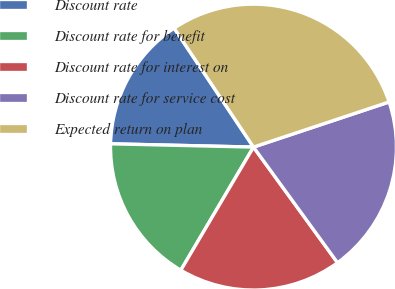<chart> <loc_0><loc_0><loc_500><loc_500><pie_chart><fcel>Discount rate<fcel>Discount rate for benefit<fcel>Discount rate for interest on<fcel>Discount rate for service cost<fcel>Expected return on plan<nl><fcel>15.27%<fcel>16.88%<fcel>18.49%<fcel>20.11%<fcel>29.25%<nl></chart> 